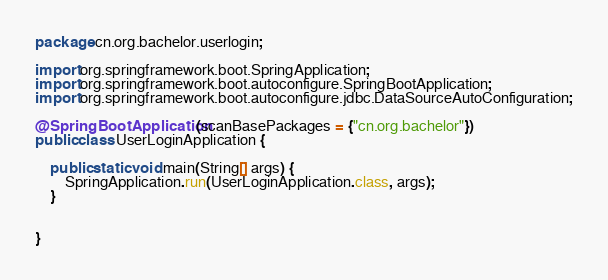<code> <loc_0><loc_0><loc_500><loc_500><_Java_>package cn.org.bachelor.userlogin;

import org.springframework.boot.SpringApplication;
import org.springframework.boot.autoconfigure.SpringBootApplication;
import org.springframework.boot.autoconfigure.jdbc.DataSourceAutoConfiguration;

@SpringBootApplication(scanBasePackages = {"cn.org.bachelor"})
public class UserLoginApplication {

    public static void main(String[] args) {
        SpringApplication.run(UserLoginApplication.class, args);
    }


}
</code> 